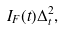Convert formula to latex. <formula><loc_0><loc_0><loc_500><loc_500>I _ { F } ( t ) \Delta _ { t } ^ { 2 } ,</formula> 